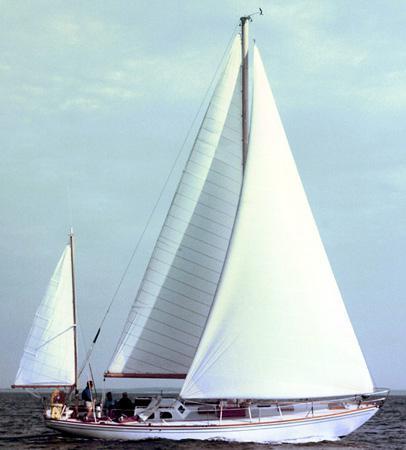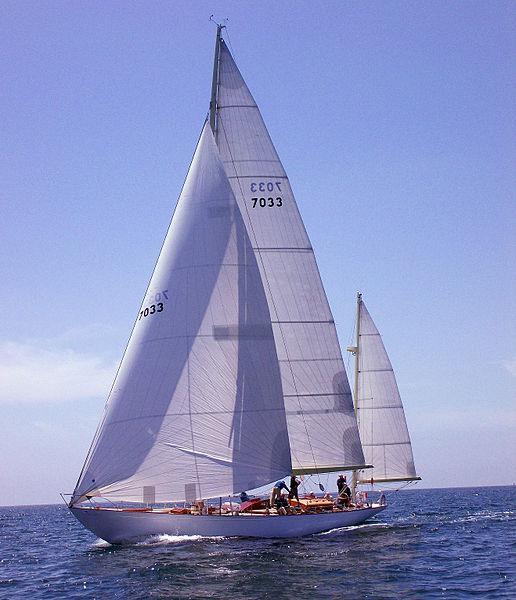The first image is the image on the left, the second image is the image on the right. Considering the images on both sides, is "There is visible land in the background of at least one image." valid? Answer yes or no. No. 